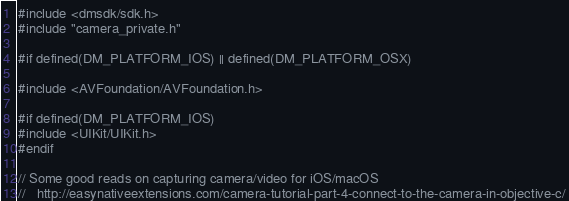Convert code to text. <code><loc_0><loc_0><loc_500><loc_500><_ObjectiveC_>#include <dmsdk/sdk.h>
#include "camera_private.h"

#if defined(DM_PLATFORM_IOS) || defined(DM_PLATFORM_OSX)

#include <AVFoundation/AVFoundation.h>

#if defined(DM_PLATFORM_IOS)
#include <UIKit/UIKit.h>
#endif

// Some good reads on capturing camera/video for iOS/macOS
//   http://easynativeextensions.com/camera-tutorial-part-4-connect-to-the-camera-in-objective-c/</code> 